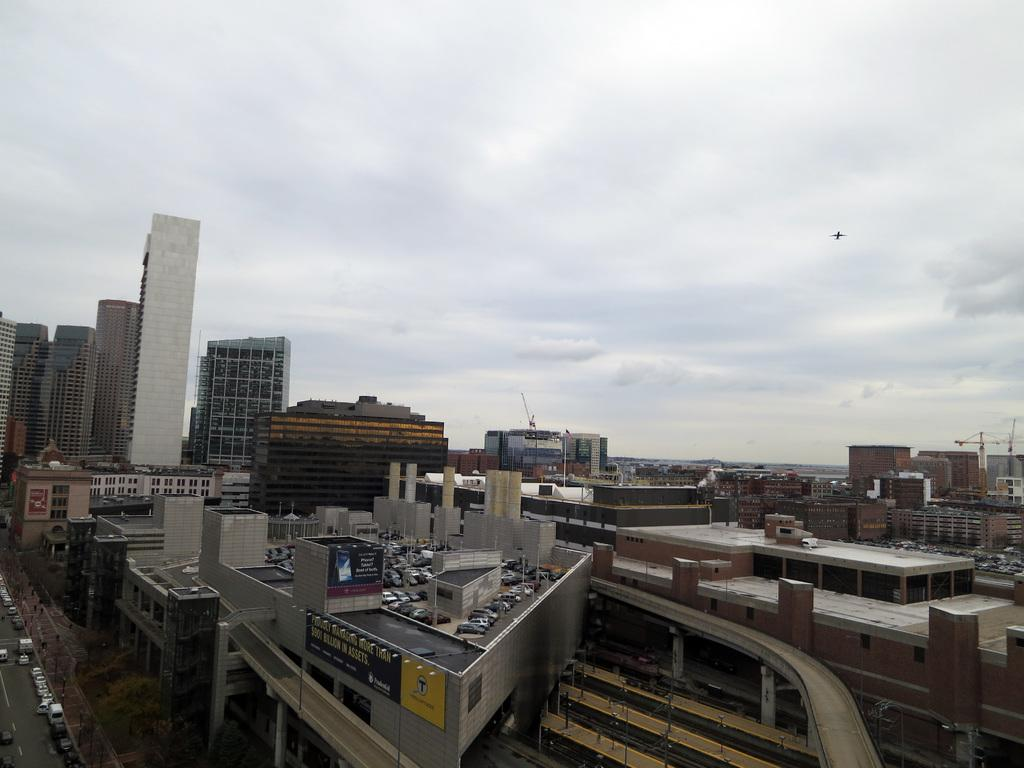What type of view is shown in the image? The image is an outside view. What can be seen in the image besides the sky? There are many buildings and cars on the road in the bottom left of the image. What is visible at the top of the image? The sky is visible at the top of the image. How many bananas can be seen hanging from the buildings in the image? There are no bananas present in the image; it features an outside view of buildings and a road with cars. Are there any bikes visible in the image? There is no mention of bikes in the provided facts, and therefore we cannot determine if any are present in the image. 